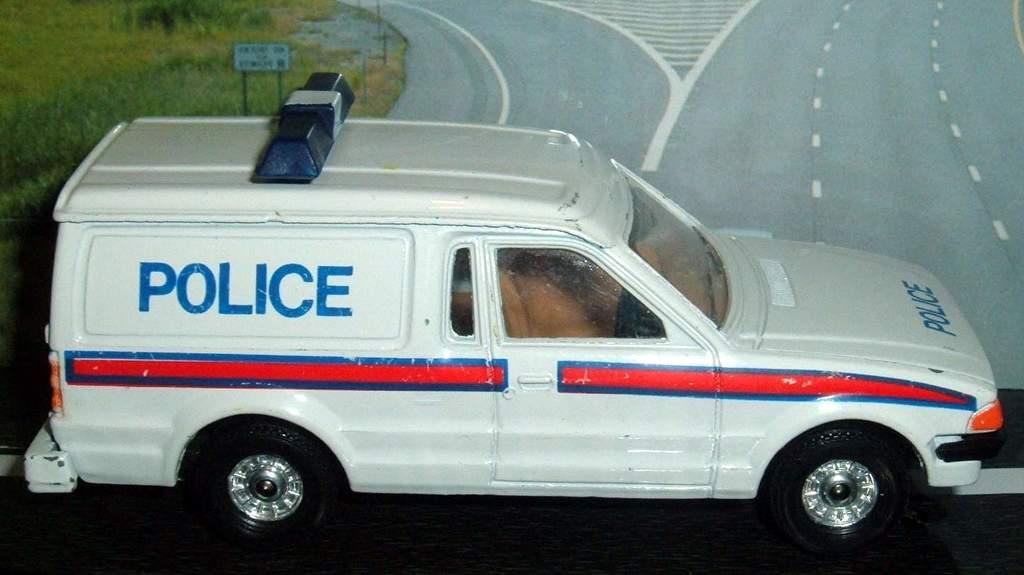What is the color of the vehicle in the image? The vehicle in the image is white. What is the vehicle doing in the image? The vehicle is moving on the road. What can be seen in the background of the image? There is grass and a road visible in the background of the image. Can you see a brain in the image? No, there is no brain present in the image. What type of cactus is growing on the side of the road in the image? There is no cactus visible in the image; only grass and a road can be seen in the background. 